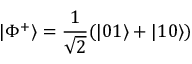<formula> <loc_0><loc_0><loc_500><loc_500>| \Phi ^ { + } \rangle = { \frac { 1 } { \sqrt { 2 } } } ( | 0 1 \rangle + | 1 0 \rangle )</formula> 